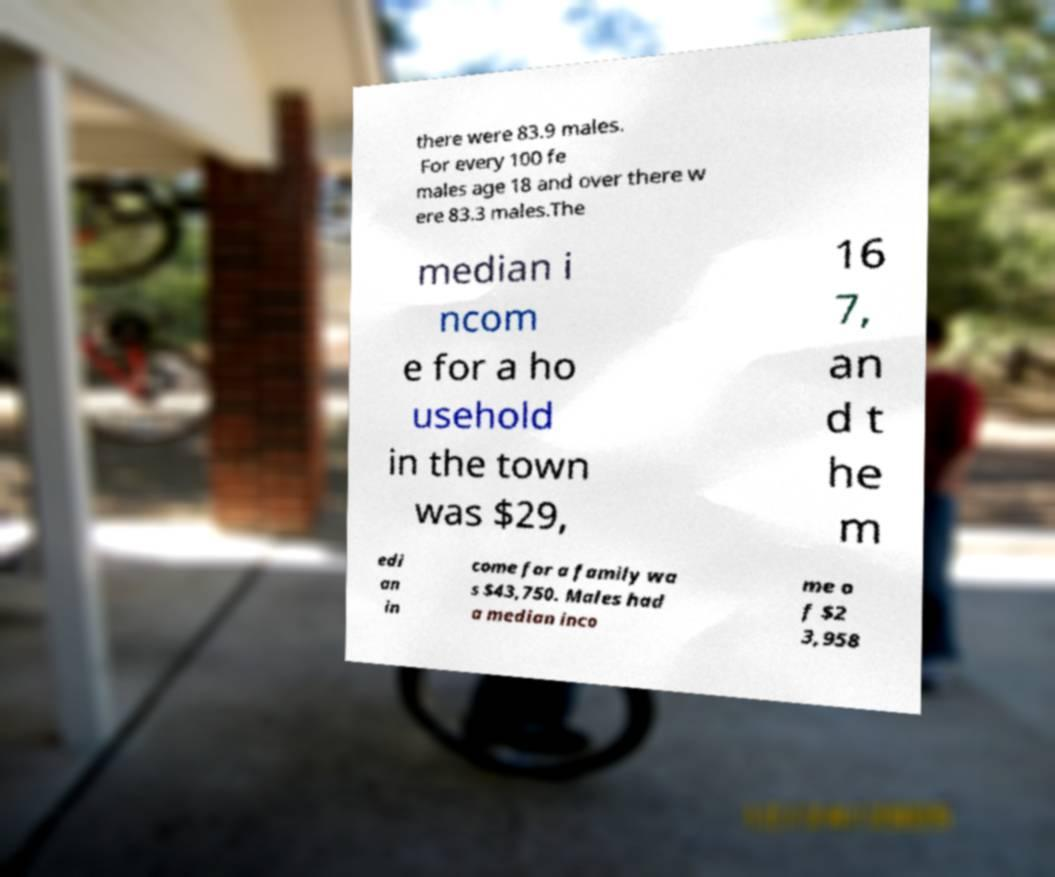I need the written content from this picture converted into text. Can you do that? there were 83.9 males. For every 100 fe males age 18 and over there w ere 83.3 males.The median i ncom e for a ho usehold in the town was $29, 16 7, an d t he m edi an in come for a family wa s $43,750. Males had a median inco me o f $2 3,958 